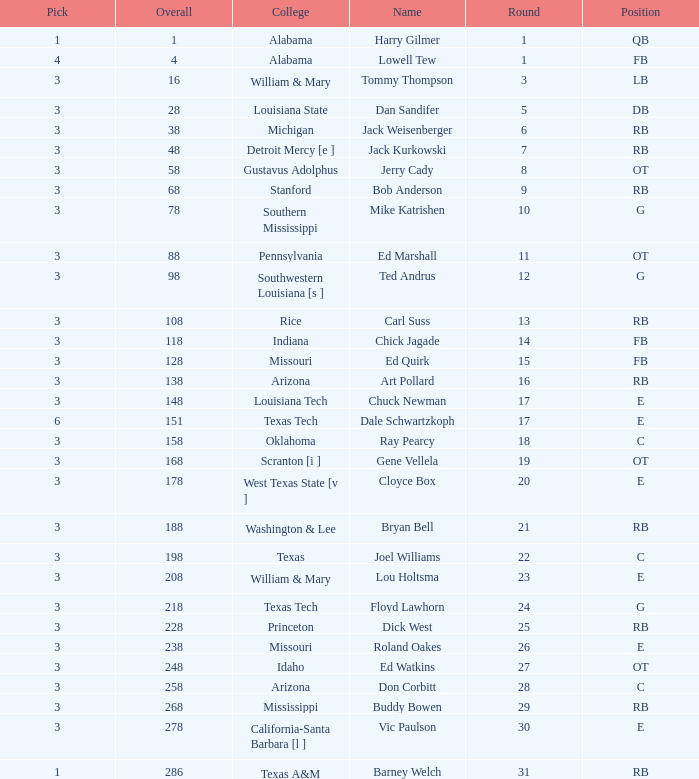Which pick has a Round smaller than 8, and an Overall smaller than 16, and a Name of harry gilmer? 1.0. 